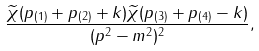<formula> <loc_0><loc_0><loc_500><loc_500>\frac { \widetilde { \chi } ( p _ { ( 1 ) } + p _ { ( 2 ) } + k ) \widetilde { \chi } ( p _ { ( 3 ) } + p _ { ( 4 ) } - k ) } { ( p ^ { 2 } - m ^ { 2 } ) ^ { 2 } } ,</formula> 